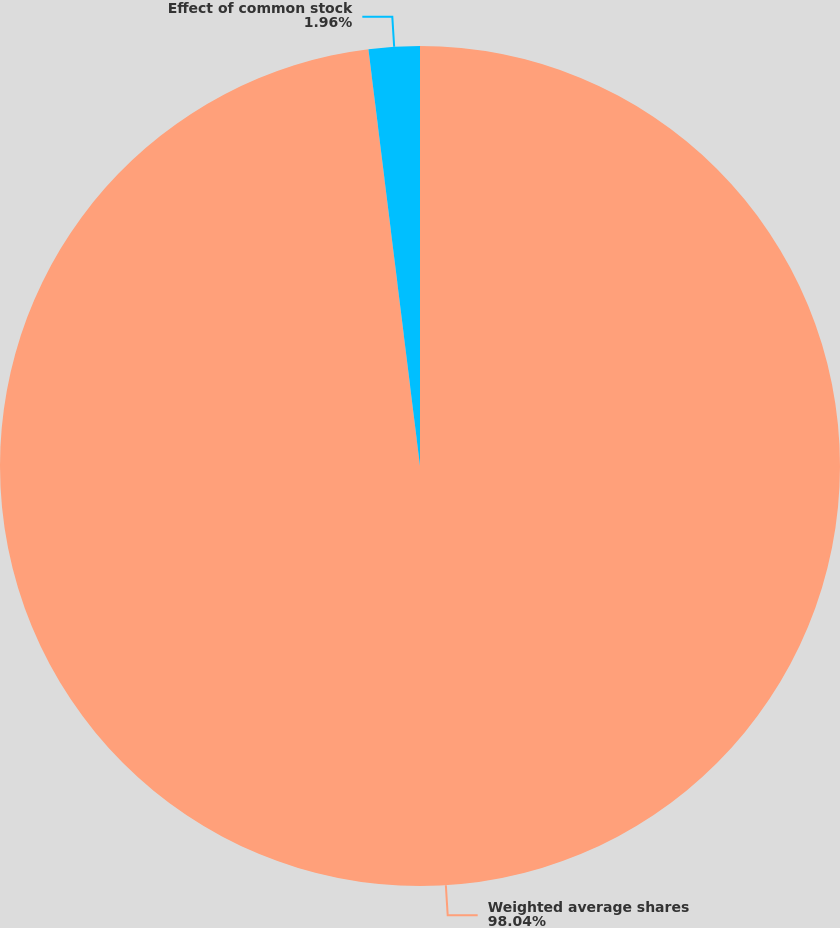<chart> <loc_0><loc_0><loc_500><loc_500><pie_chart><fcel>Weighted average shares<fcel>Effect of common stock<nl><fcel>98.04%<fcel>1.96%<nl></chart> 